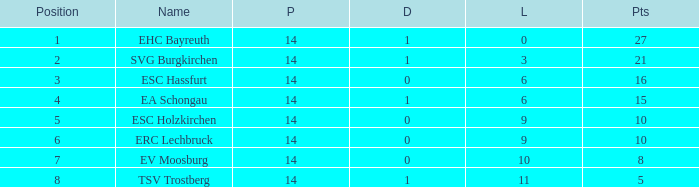What's the most points for Ea Schongau with more than 1 drawn? None. Can you parse all the data within this table? {'header': ['Position', 'Name', 'P', 'D', 'L', 'Pts'], 'rows': [['1', 'EHC Bayreuth', '14', '1', '0', '27'], ['2', 'SVG Burgkirchen', '14', '1', '3', '21'], ['3', 'ESC Hassfurt', '14', '0', '6', '16'], ['4', 'EA Schongau', '14', '1', '6', '15'], ['5', 'ESC Holzkirchen', '14', '0', '9', '10'], ['6', 'ERC Lechbruck', '14', '0', '9', '10'], ['7', 'EV Moosburg', '14', '0', '10', '8'], ['8', 'TSV Trostberg', '14', '1', '11', '5']]} 